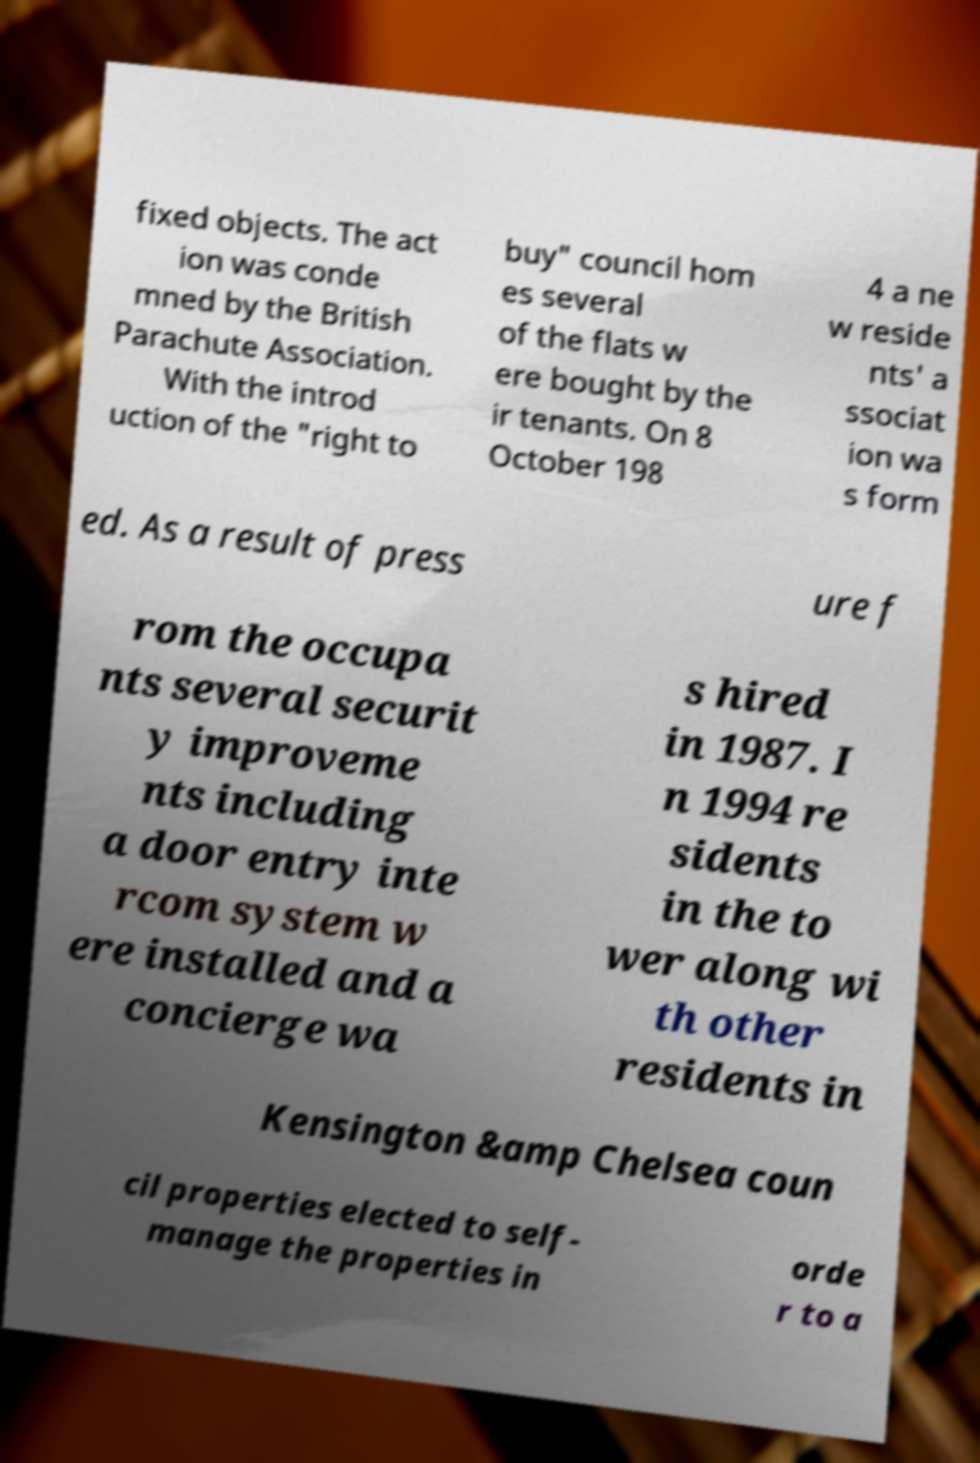Can you read and provide the text displayed in the image?This photo seems to have some interesting text. Can you extract and type it out for me? fixed objects. The act ion was conde mned by the British Parachute Association. With the introd uction of the "right to buy" council hom es several of the flats w ere bought by the ir tenants. On 8 October 198 4 a ne w reside nts' a ssociat ion wa s form ed. As a result of press ure f rom the occupa nts several securit y improveme nts including a door entry inte rcom system w ere installed and a concierge wa s hired in 1987. I n 1994 re sidents in the to wer along wi th other residents in Kensington &amp Chelsea coun cil properties elected to self- manage the properties in orde r to a 